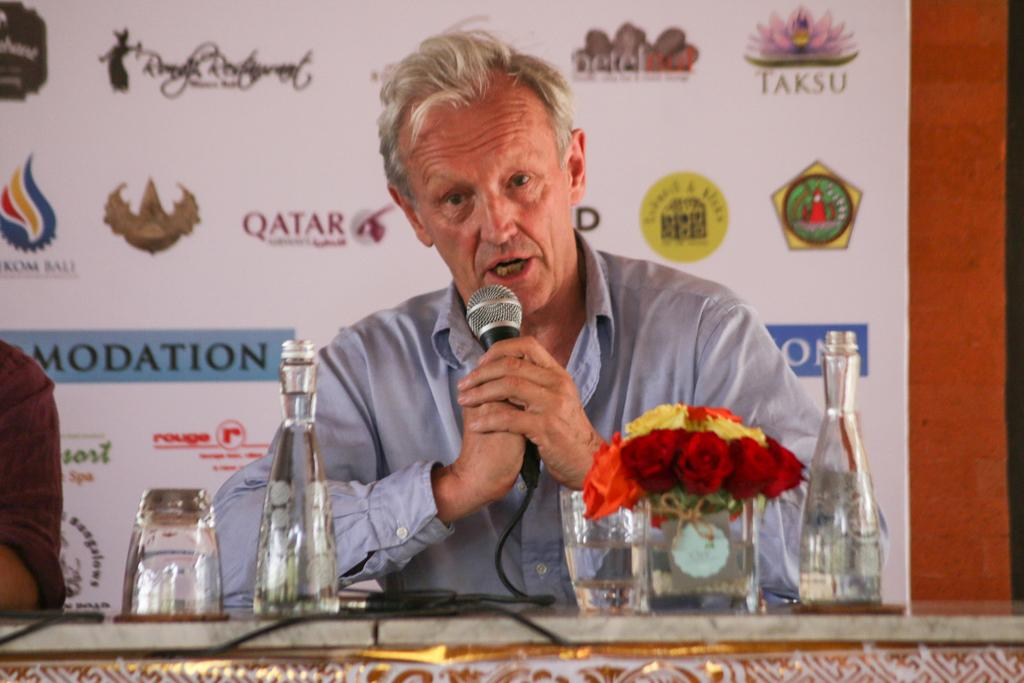<image>
Share a concise interpretation of the image provided. A coach gives a press conference that is sponsored by compiles like Taksu 